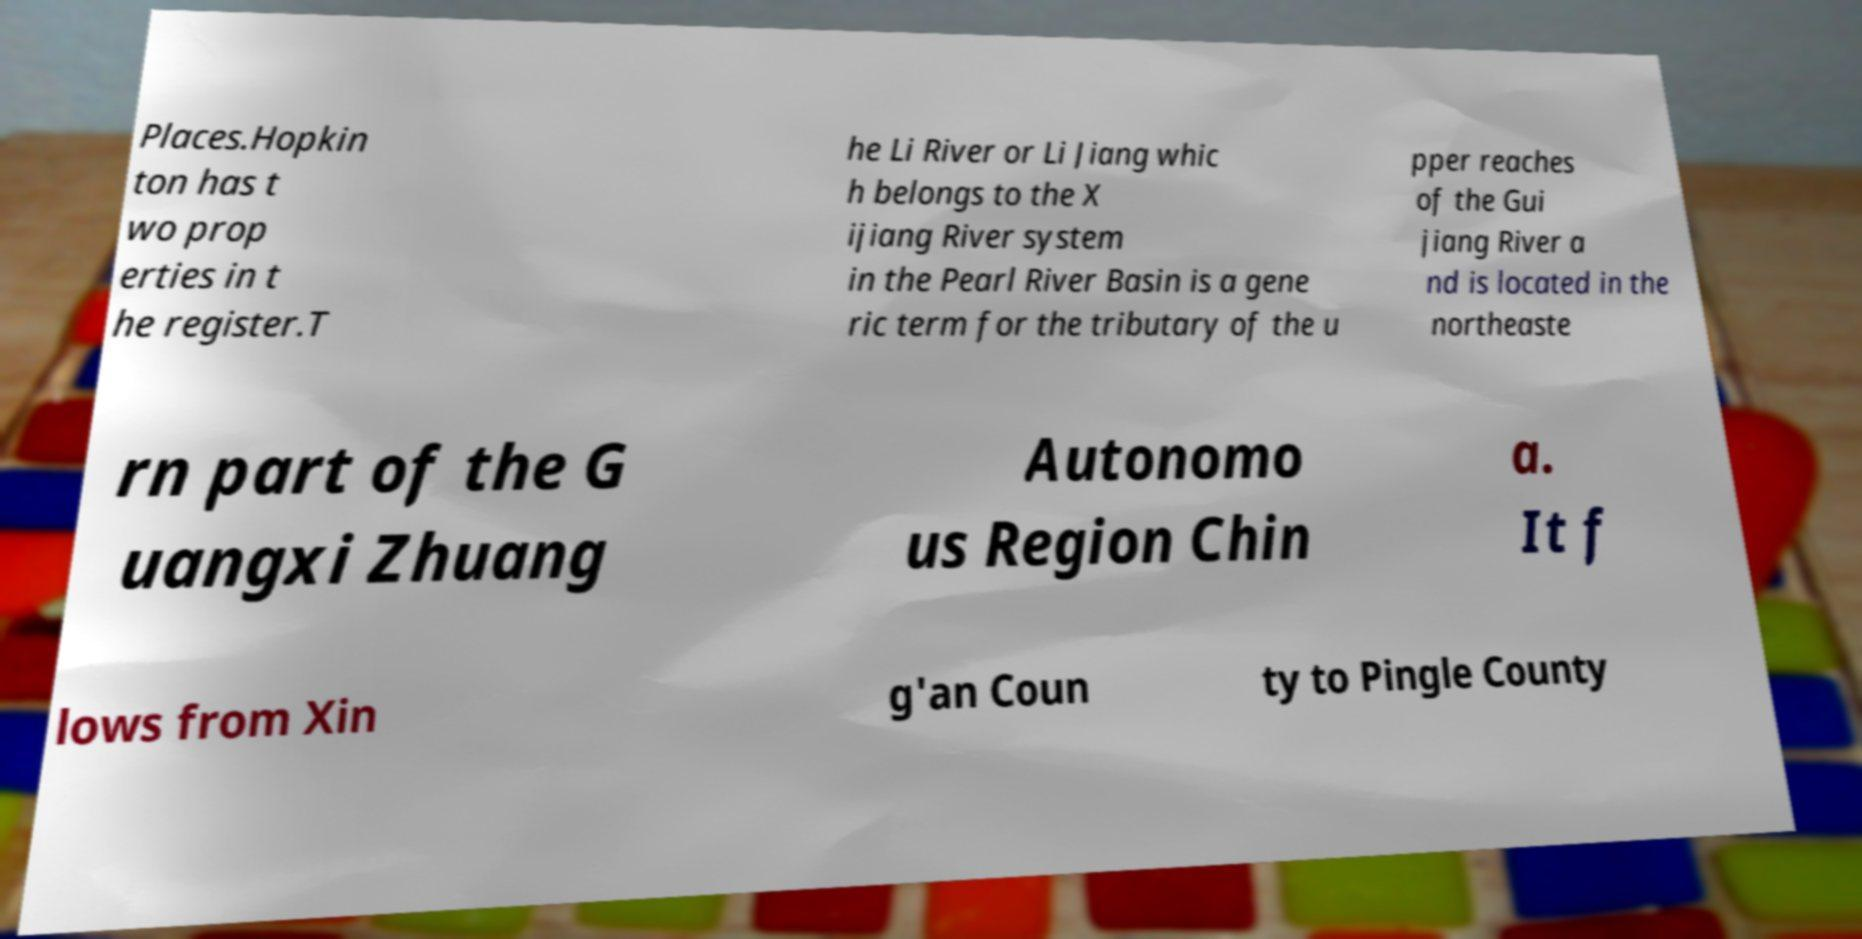Can you read and provide the text displayed in the image?This photo seems to have some interesting text. Can you extract and type it out for me? Places.Hopkin ton has t wo prop erties in t he register.T he Li River or Li Jiang whic h belongs to the X ijiang River system in the Pearl River Basin is a gene ric term for the tributary of the u pper reaches of the Gui jiang River a nd is located in the northeaste rn part of the G uangxi Zhuang Autonomo us Region Chin a. It f lows from Xin g'an Coun ty to Pingle County 